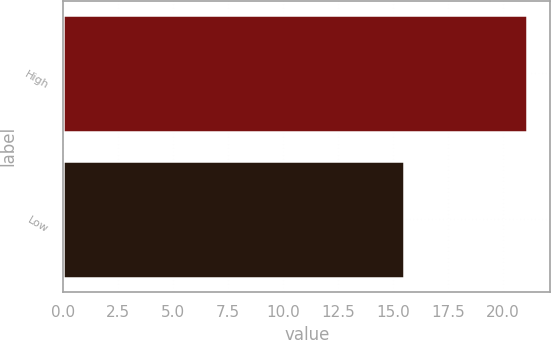Convert chart to OTSL. <chart><loc_0><loc_0><loc_500><loc_500><bar_chart><fcel>High<fcel>Low<nl><fcel>21.1<fcel>15.51<nl></chart> 